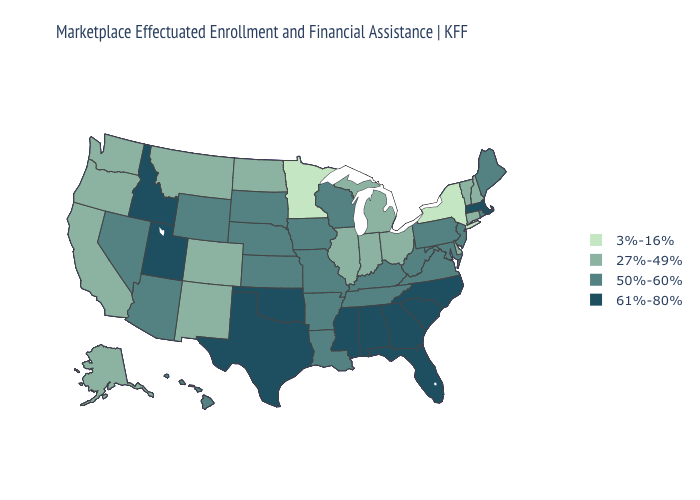What is the value of Illinois?
Concise answer only. 27%-49%. Is the legend a continuous bar?
Keep it brief. No. Does Michigan have a lower value than Vermont?
Be succinct. No. Does New Mexico have the same value as Montana?
Write a very short answer. Yes. What is the highest value in the Northeast ?
Be succinct. 61%-80%. Does Wisconsin have a higher value than Washington?
Quick response, please. Yes. Which states have the lowest value in the USA?
Quick response, please. Minnesota, New York. Among the states that border Michigan , does Ohio have the highest value?
Concise answer only. No. Name the states that have a value in the range 50%-60%?
Give a very brief answer. Arizona, Arkansas, Hawaii, Iowa, Kansas, Kentucky, Louisiana, Maine, Maryland, Missouri, Nebraska, Nevada, New Jersey, Pennsylvania, Rhode Island, South Dakota, Tennessee, Virginia, West Virginia, Wisconsin, Wyoming. Name the states that have a value in the range 50%-60%?
Give a very brief answer. Arizona, Arkansas, Hawaii, Iowa, Kansas, Kentucky, Louisiana, Maine, Maryland, Missouri, Nebraska, Nevada, New Jersey, Pennsylvania, Rhode Island, South Dakota, Tennessee, Virginia, West Virginia, Wisconsin, Wyoming. Does Massachusetts have the highest value in the Northeast?
Concise answer only. Yes. What is the value of Idaho?
Short answer required. 61%-80%. What is the lowest value in the USA?
Concise answer only. 3%-16%. What is the highest value in the Northeast ?
Short answer required. 61%-80%. What is the value of Idaho?
Answer briefly. 61%-80%. 